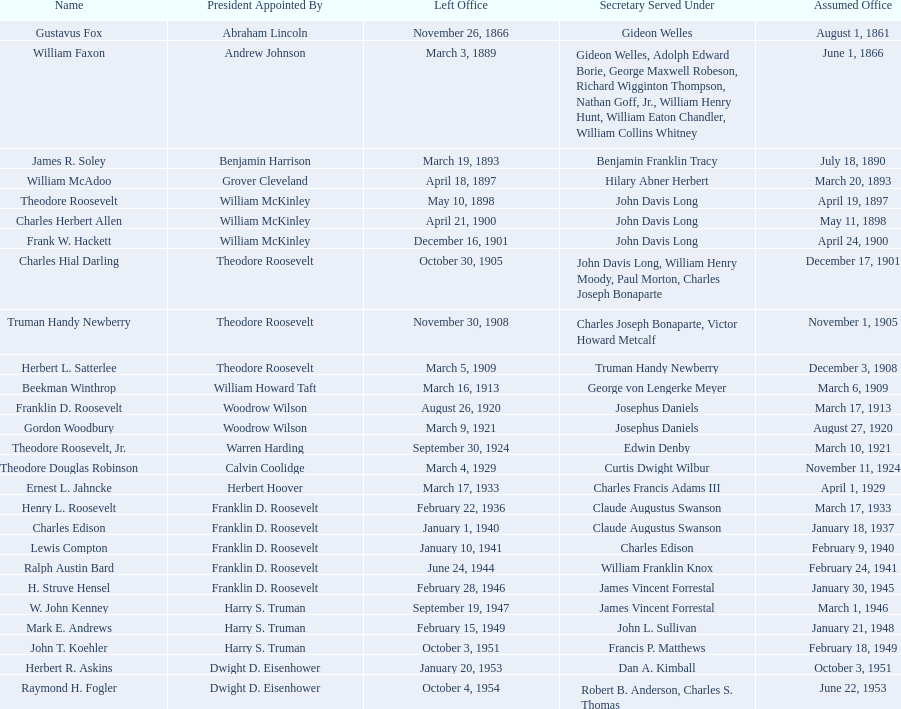Who were all the assistant secretary's of the navy? Gustavus Fox, William Faxon, James R. Soley, William McAdoo, Theodore Roosevelt, Charles Herbert Allen, Frank W. Hackett, Charles Hial Darling, Truman Handy Newberry, Herbert L. Satterlee, Beekman Winthrop, Franklin D. Roosevelt, Gordon Woodbury, Theodore Roosevelt, Jr., Theodore Douglas Robinson, Ernest L. Jahncke, Henry L. Roosevelt, Charles Edison, Lewis Compton, Ralph Austin Bard, H. Struve Hensel, W. John Kenney, Mark E. Andrews, John T. Koehler, Herbert R. Askins, Raymond H. Fogler. What are the various dates they left office in? November 26, 1866, March 3, 1889, March 19, 1893, April 18, 1897, May 10, 1898, April 21, 1900, December 16, 1901, October 30, 1905, November 30, 1908, March 5, 1909, March 16, 1913, August 26, 1920, March 9, 1921, September 30, 1924, March 4, 1929, March 17, 1933, February 22, 1936, January 1, 1940, January 10, 1941, June 24, 1944, February 28, 1946, September 19, 1947, February 15, 1949, October 3, 1951, January 20, 1953, October 4, 1954. Of these dates, which was the date raymond h. fogler left office in? October 4, 1954. 